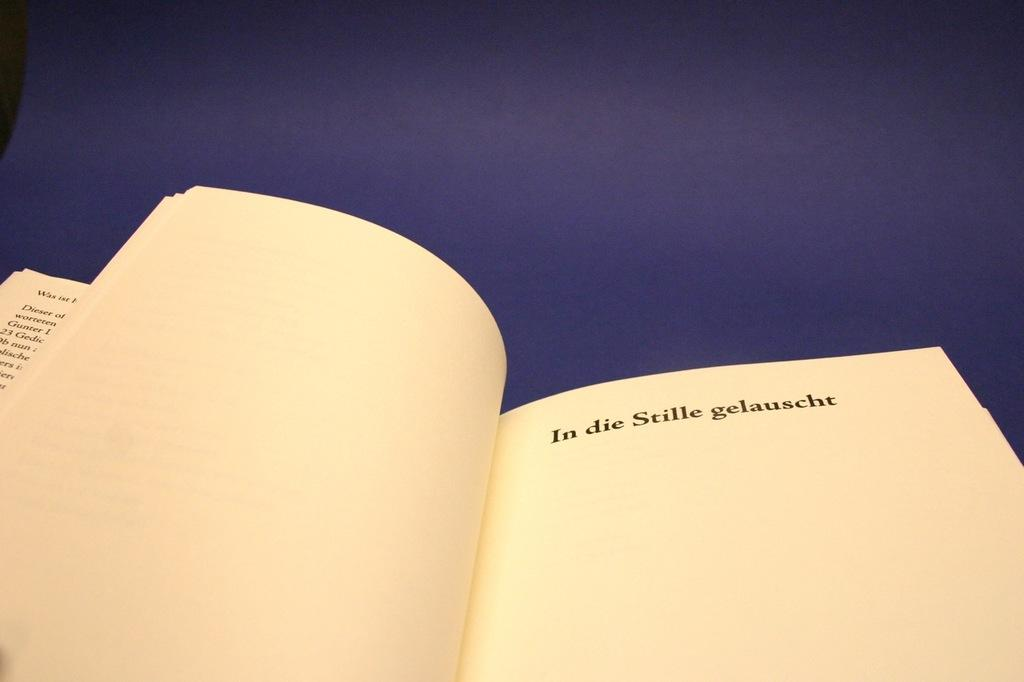Provide a one-sentence caption for the provided image. A book is open with the words "In die Stille gelauscht" bolded at the top of the page. 